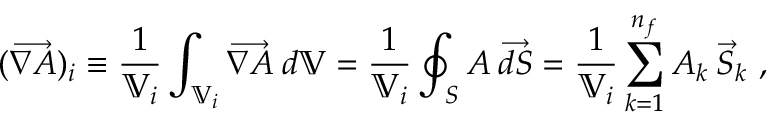<formula> <loc_0><loc_0><loc_500><loc_500>( \overrightarrow { \nabla A } ) _ { i } \equiv \frac { 1 } { \mathbb { V } _ { i } } \int _ { \mathbb { V } _ { i } } \overrightarrow { \nabla A } \, d \mathbb { V } = \frac { 1 } { \mathbb { V } _ { i } } \oint _ { S } A \, \overrightarrow { d S } = \frac { 1 } { \mathbb { V } _ { i } } \sum _ { k = 1 } ^ { n _ { f } } A _ { k } \, \vec { S } _ { k } ,</formula> 